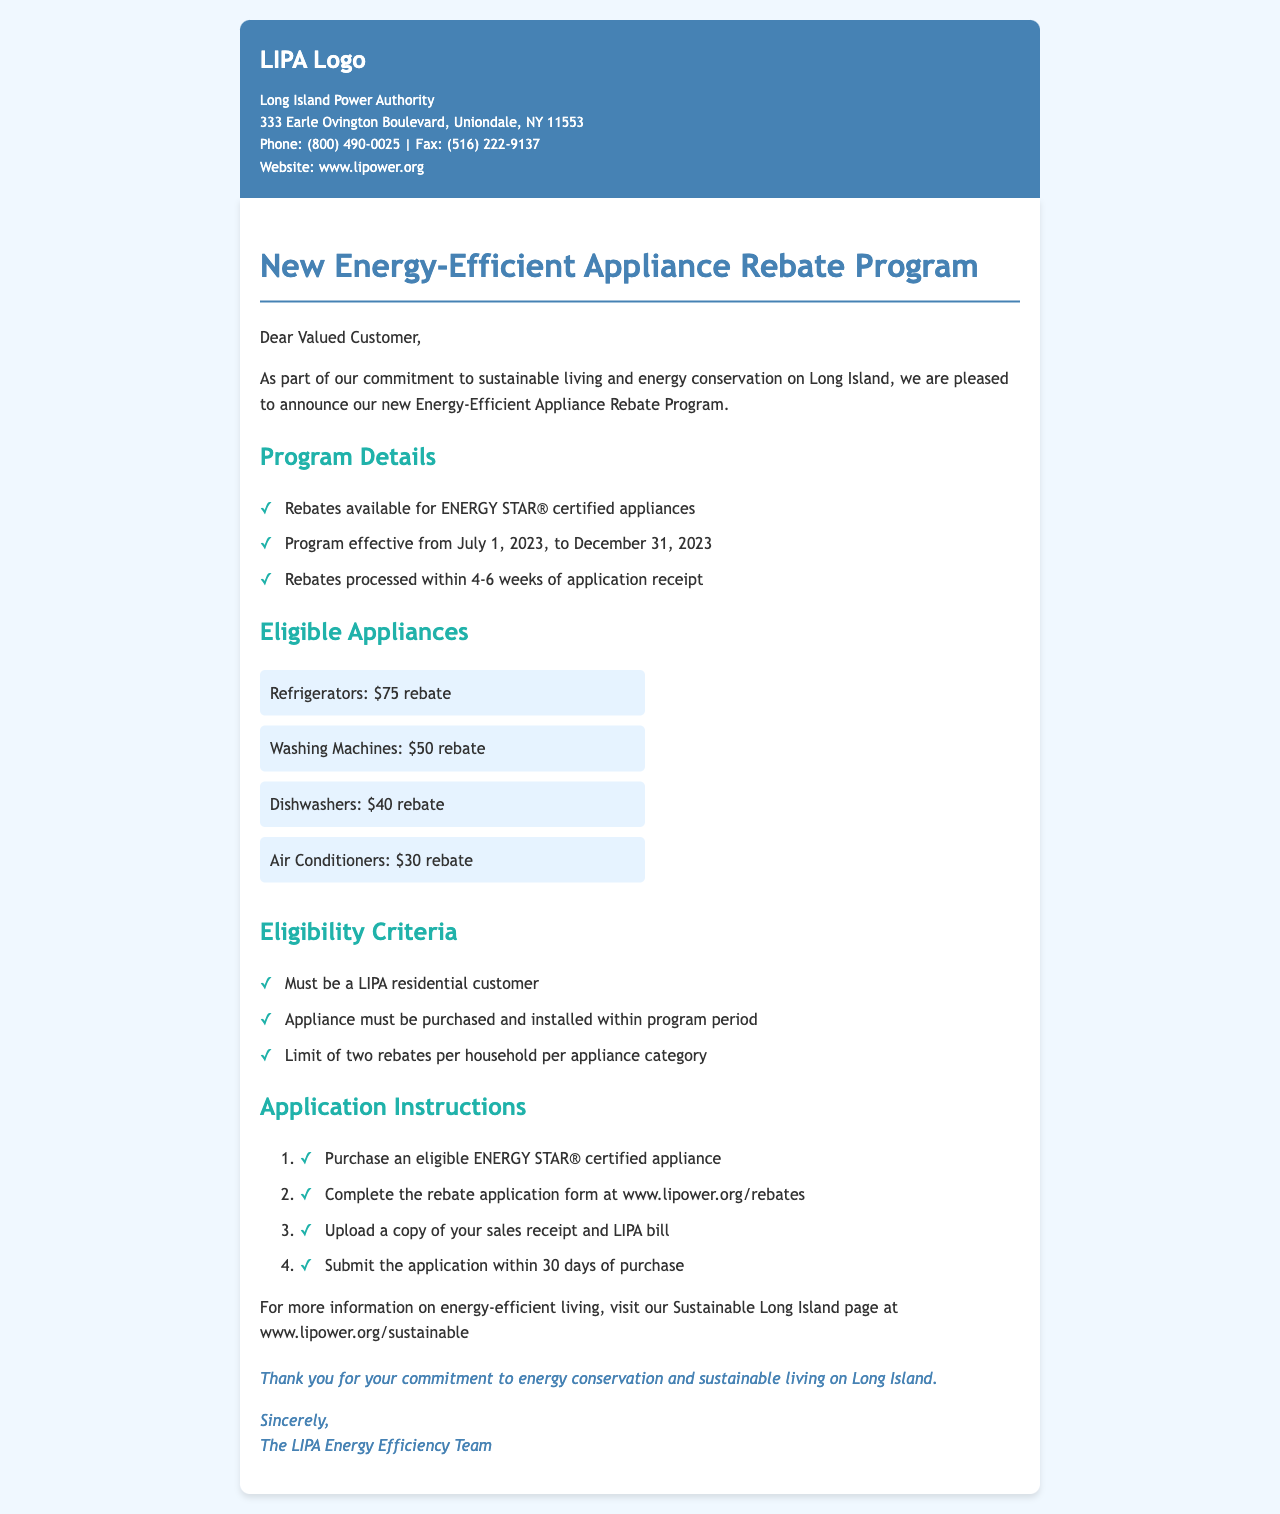What is the program called? The document outlines a rebate program specifically designed for energy-efficient appliances.
Answer: Energy-Efficient Appliance Rebate Program When does the rebate program start? The program has a designated start date mentioned in the document.
Answer: July 1, 2023 What is the rebate amount for refrigerators? The document lists specific rebate amounts for different appliances, including refrigerators.
Answer: $75 rebate How long will it take to process the rebates? The document specifies the timeframe for rebate processing after application submission.
Answer: 4-6 weeks How many rebates can a household claim per appliance category? The eligibility criteria include a limit on the number of rebates.
Answer: Two rebates What must be uploaded with the application? The application instructions outline the required documents for submission.
Answer: Sales receipt and LIPA bill Where can more information on energy-efficient living be found? The document provides a specific web page for additional information on sustainable practices.
Answer: www.lipower.org/sustainable Who is eligible for the rebate program? The eligibility criteria specify who can participate in the program.
Answer: LIPA residential customer What is the rebate amount for washing machines? The document lists the specific rebate amounts for various appliances, including washing machines.
Answer: $50 rebate 